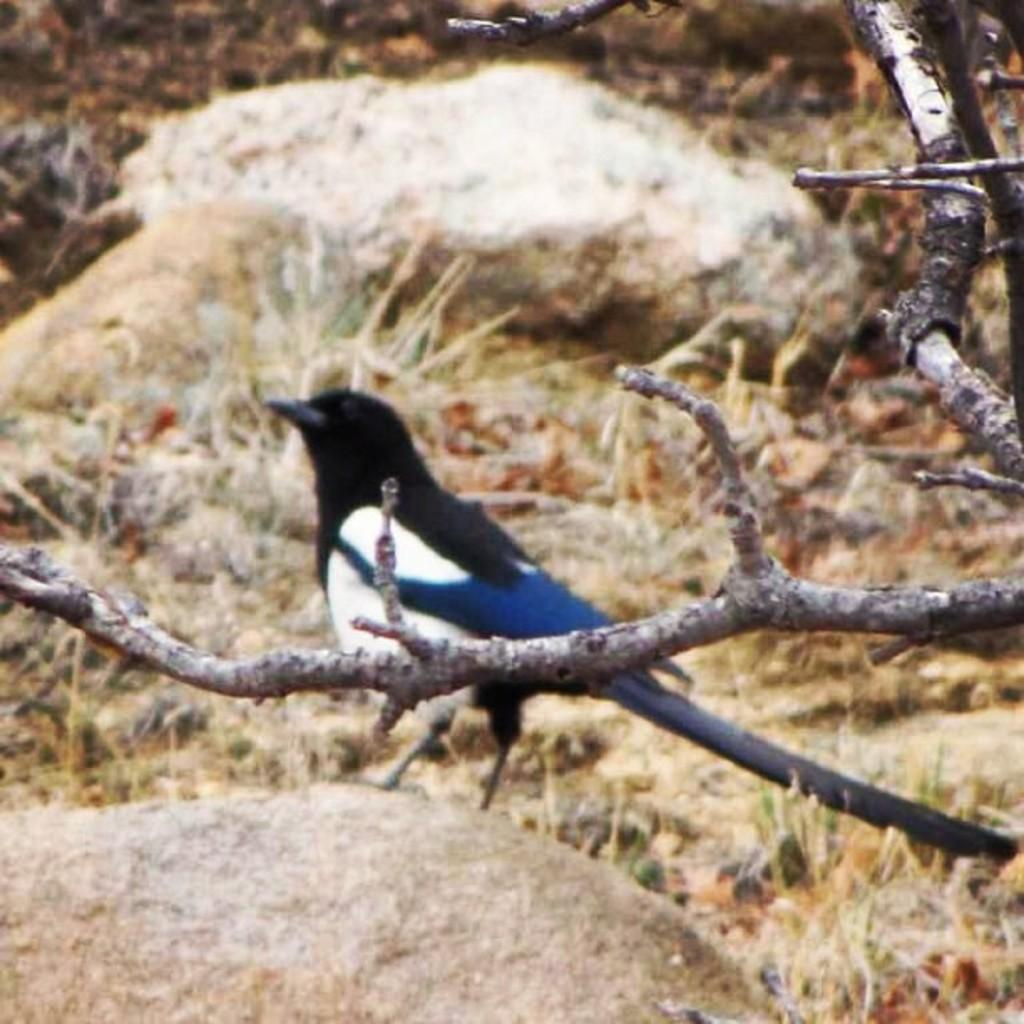What type of animal is in the image? There is a bird in the image. Where is the bird located? The bird is on a rock. What type of vegetation is visible in the image? There is grass visible in the image. What else can be seen in the image besides the bird and grass? There is a tree branch in the image. What colors can be seen on the bird? The bird has white, black, and blue coloring. What type of friction is the bird experiencing on the rock? The bird's experience of friction on the rock cannot be determined from the image. How does the van affect the bird's behavior in the image? There is no van present in the image, so its effect on the bird's behavior cannot be determined. 